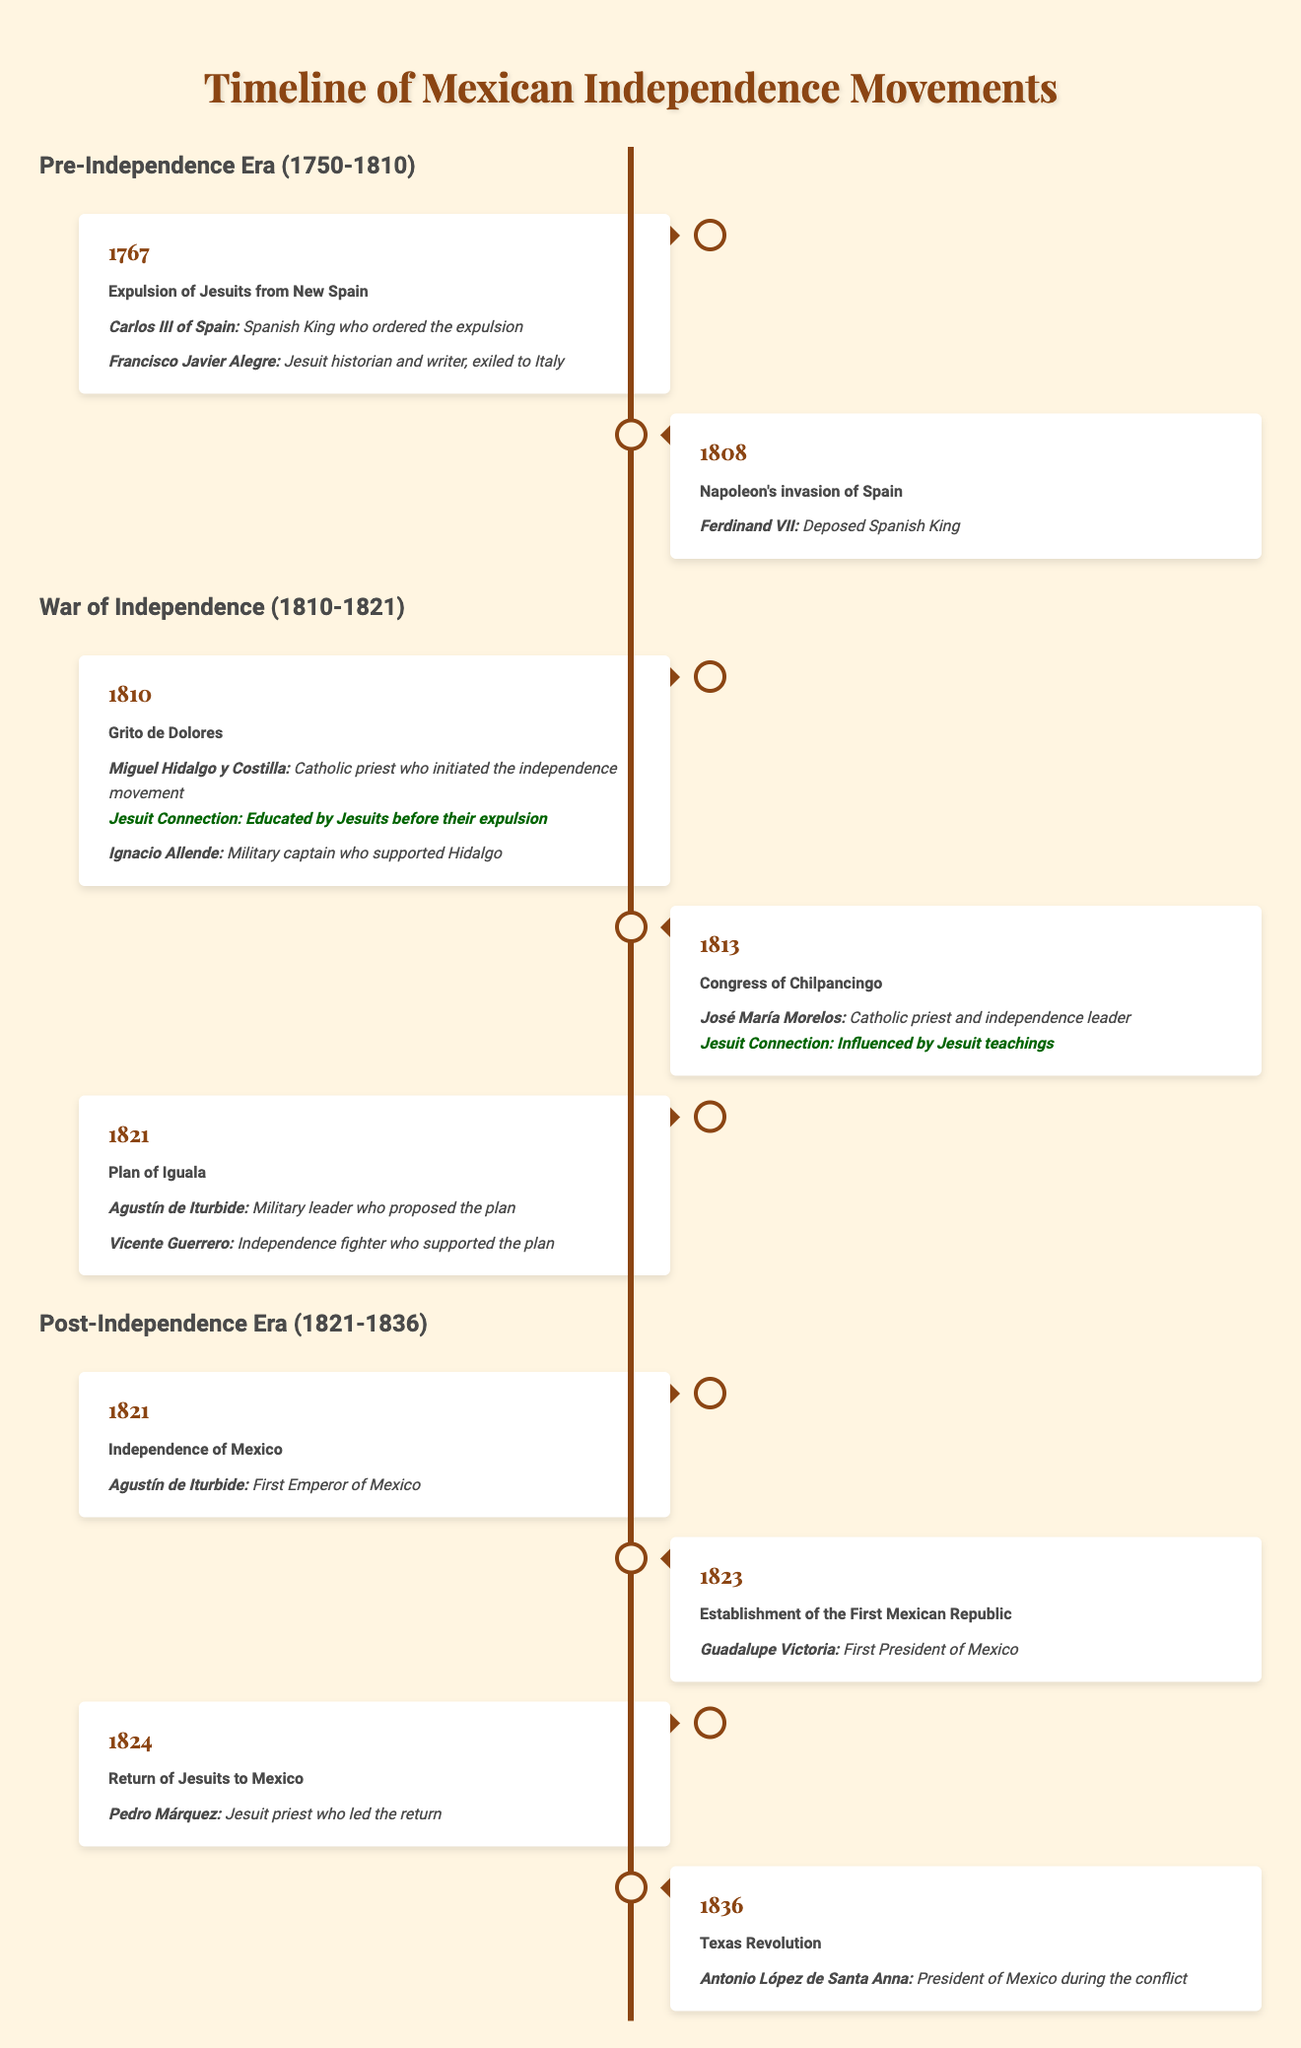What year did the Jesuits get expelled from New Spain? The table specifically lists the year 1767 under the key event "Expulsion of Jesuits from New Spain."
Answer: 1767 Who was the Spanish King that ordered the expulsion of the Jesuits? The table identifies Carlos III of Spain as the Spanish King who ordered the expulsion.
Answer: Carlos III of Spain Which key figure from the War of Independence was educated by Jesuits? The table indicates that Miguel Hidalgo y Costilla was educated by Jesuits before their expulsion.
Answer: Miguel Hidalgo y Costilla In what year did Mexico gain independence? The table states that Mexico achieved independence in the year 1821.
Answer: 1821 How many key events are listed during the War of Independence period? The table lists three key events under the "War of Independence" period, which are the Grito de Dolores in 1810, the Congress of Chilpancingo in 1813, and the Plan of Iguala in 1821.
Answer: 3 Is José María Morelos a key figure in the War of Independence? The table confirms that José María Morelos is listed as a key figure in the War of Independence under the Congress of Chilpancingo event.
Answer: Yes Which event is associated with the year 1824? The table mentions the "Return of Jesuits to Mexico" as the event associated with the year 1824.
Answer: Return of Jesuits to Mexico Name one key figure from the event "Plan of Iguala." The table lists Agustín de Iturbide as one key figure from the Plan of Iguala event in 1821.
Answer: Agustín de Iturbide How many key figures are directly associated with the event "Grito de Dolores"? There are two key figures associated with the event "Grito de Dolores": Miguel Hidalgo y Costilla and Ignacio Allende.
Answer: 2 Which period includes the establishment of the First Mexican Republic? The establishment of the First Mexican Republic occurred in the year 1823, which is included in the Post-Independence Era.
Answer: Post-Independence Era Identify a key figure from the Post-Independence Era who was involved in the Texas Revolution. According to the table, Antonio López de Santa Anna is the key figure from the Post-Independence Era involved in the Texas Revolution.
Answer: Antonio López de Santa Anna What is the relationship between José María Morelos and Jesuit teachings? The table states that José María Morelos was influenced by Jesuit teachings, indicating a significant connection.
Answer: Influenced by Jesuit teachings How many years passed between the expulsion of the Jesuits and the return of Jesuits to Mexico? The expulsion occurred in 1767 and the return was in 1824. The difference is 1824 - 1767 = 57 years.
Answer: 57 years Was Vicente Guerrero a military leader who supported the Plan of Iguala? The table identifies Vicente Guerrero as an independence fighter who supported the Plan of Iguala but does not define him as a military leader.
Answer: No List two key events that took place in 1821. The table shows two events in 1821: the Independence of Mexico and the Plan of Iguala.
Answer: Independence of Mexico and Plan of Iguala What significant event took place in the year 1808 that influenced Mexican independence? The table notes that Napoleon's invasion of Spain in 1808 had a significant impact on the impetus for the independence movement.
Answer: Napoleon's invasion of Spain 